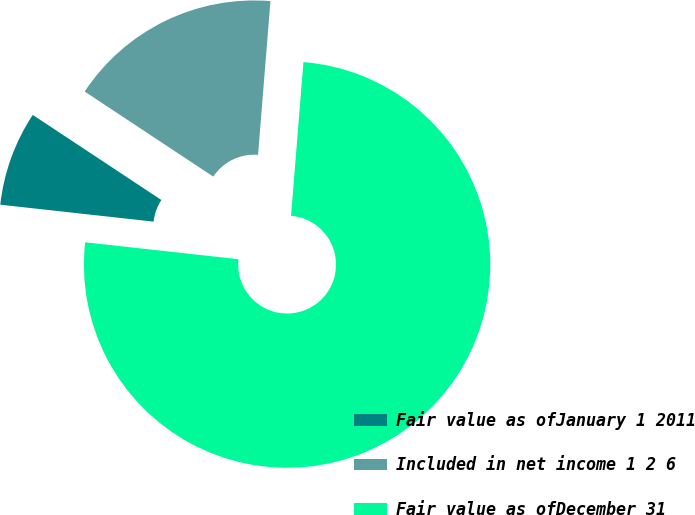<chart> <loc_0><loc_0><loc_500><loc_500><pie_chart><fcel>Fair value as ofJanuary 1 2011<fcel>Included in net income 1 2 6<fcel>Fair value as ofDecember 31<nl><fcel>7.55%<fcel>16.98%<fcel>75.47%<nl></chart> 